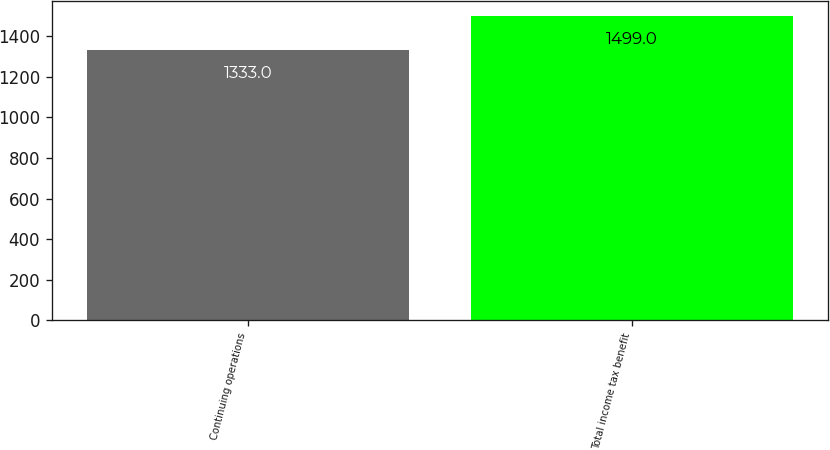Convert chart to OTSL. <chart><loc_0><loc_0><loc_500><loc_500><bar_chart><fcel>Continuing operations<fcel>Total income tax benefit<nl><fcel>1333<fcel>1499<nl></chart> 